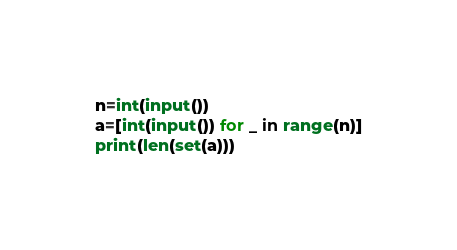<code> <loc_0><loc_0><loc_500><loc_500><_Python_>n=int(input())
a=[int(input()) for _ in range(n)]
print(len(set(a)))</code> 